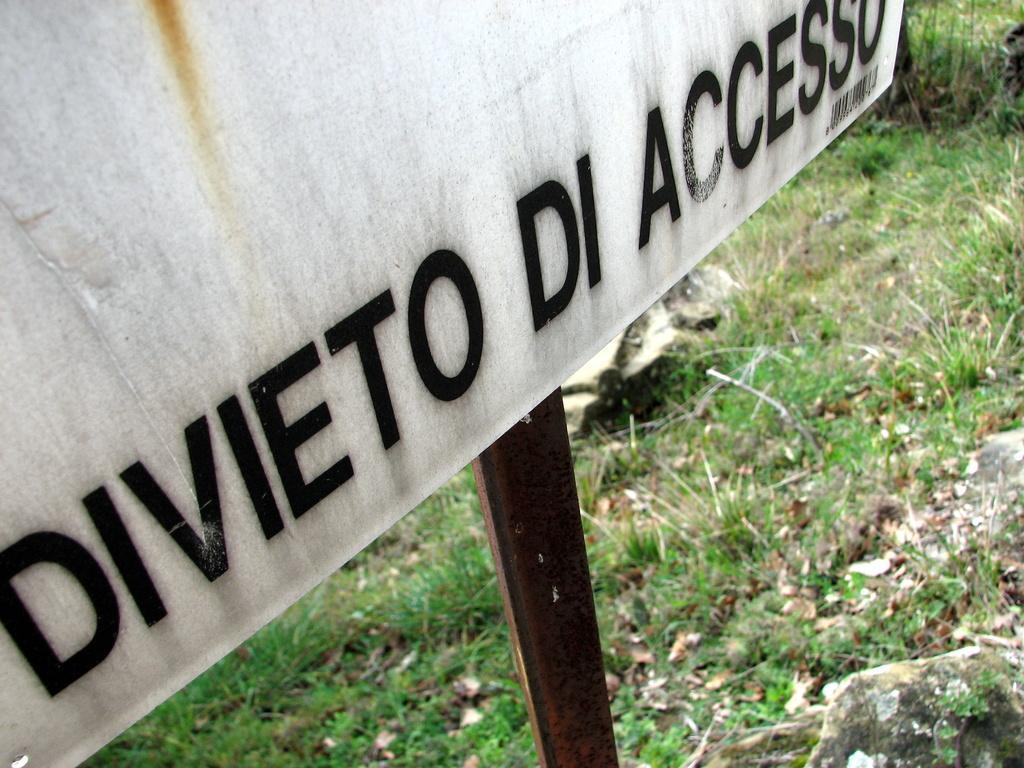Can you describe this image briefly? This image consists of a board in white color. Is attached to a rod which is made up of metal. At the bottom, there is green grass and rocks. 